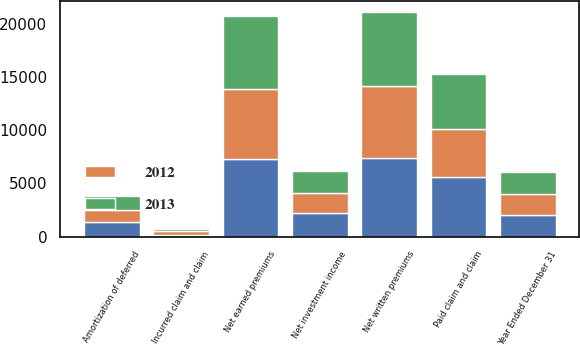<chart> <loc_0><loc_0><loc_500><loc_500><stacked_bar_chart><ecel><fcel>Year Ended December 31<fcel>Net written premiums<fcel>Net earned premiums<fcel>Net investment income<fcel>Incurred claim and claim<fcel>Amortization of deferred<fcel>Paid claim and claim<nl><fcel>nan<fcel>2013<fcel>7348<fcel>7271<fcel>2240<fcel>115<fcel>1362<fcel>5566<nl><fcel>2013<fcel>2012<fcel>6964<fcel>6881<fcel>2074<fcel>180<fcel>1274<fcel>5257<nl><fcel>2012<fcel>2011<fcel>6798<fcel>6603<fcel>1845<fcel>429<fcel>1176<fcel>4499<nl></chart> 